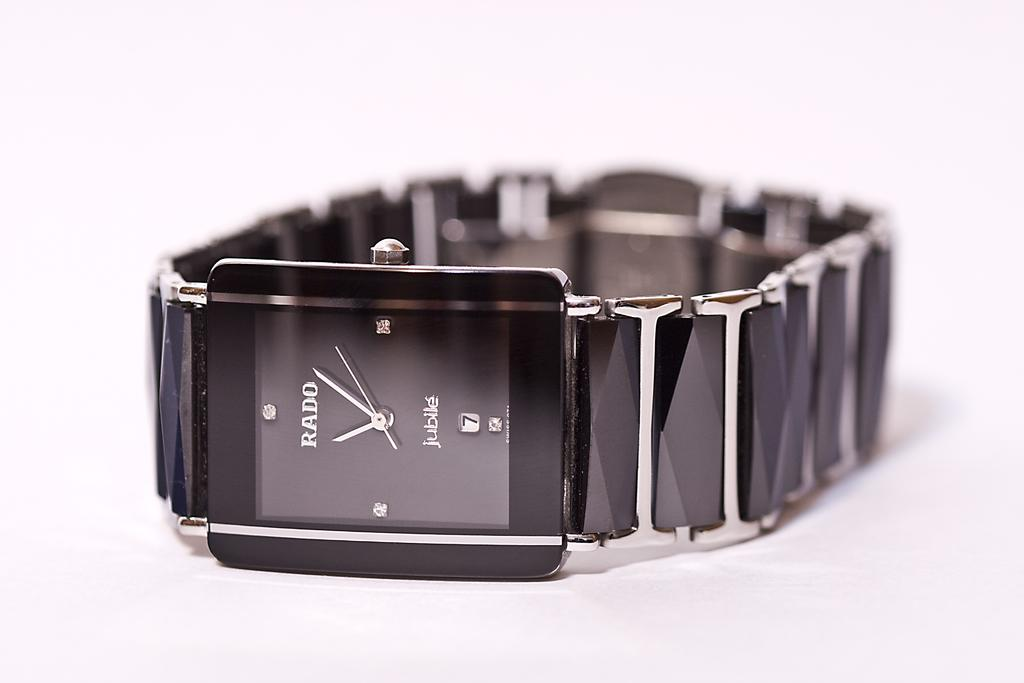Provide a one-sentence caption for the provided image. A sleek Rado Jubile watch laying on a white surface. 